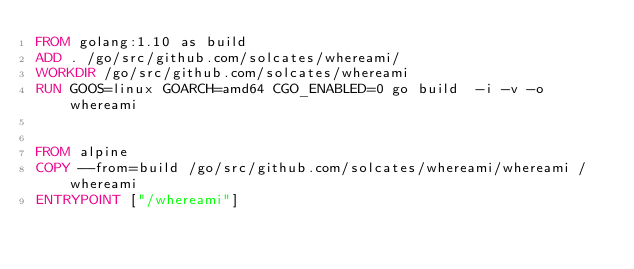<code> <loc_0><loc_0><loc_500><loc_500><_Dockerfile_>FROM golang:1.10 as build
ADD . /go/src/github.com/solcates/whereami/
WORKDIR /go/src/github.com/solcates/whereami
RUN GOOS=linux GOARCH=amd64 CGO_ENABLED=0 go build  -i -v -o whereami


FROM alpine
COPY --from=build /go/src/github.com/solcates/whereami/whereami /whereami
ENTRYPOINT ["/whereami"]</code> 